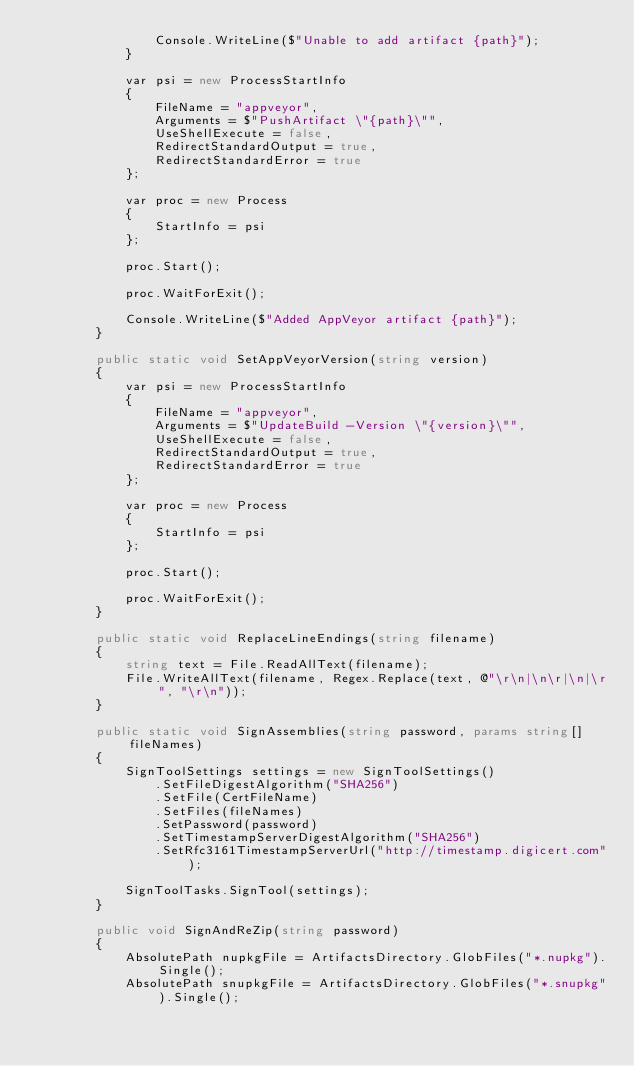Convert code to text. <code><loc_0><loc_0><loc_500><loc_500><_C#_>                Console.WriteLine($"Unable to add artifact {path}");
            }

            var psi = new ProcessStartInfo
            {
                FileName = "appveyor",
                Arguments = $"PushArtifact \"{path}\"",
                UseShellExecute = false,
                RedirectStandardOutput = true,
                RedirectStandardError = true
            };

            var proc = new Process
            {
                StartInfo = psi
            };

            proc.Start();

            proc.WaitForExit();

            Console.WriteLine($"Added AppVeyor artifact {path}");
        }

        public static void SetAppVeyorVersion(string version)
        {
            var psi = new ProcessStartInfo
            {
                FileName = "appveyor",
                Arguments = $"UpdateBuild -Version \"{version}\"",
                UseShellExecute = false,
                RedirectStandardOutput = true,
                RedirectStandardError = true
            };

            var proc = new Process
            {
                StartInfo = psi
            };

            proc.Start();

            proc.WaitForExit();
        }

        public static void ReplaceLineEndings(string filename)
        {
            string text = File.ReadAllText(filename);
            File.WriteAllText(filename, Regex.Replace(text, @"\r\n|\n\r|\n|\r", "\r\n"));
        }

        public static void SignAssemblies(string password, params string[] fileNames)
        {
            SignToolSettings settings = new SignToolSettings()
                .SetFileDigestAlgorithm("SHA256")
                .SetFile(CertFileName)
                .SetFiles(fileNames)
                .SetPassword(password)
                .SetTimestampServerDigestAlgorithm("SHA256")
                .SetRfc3161TimestampServerUrl("http://timestamp.digicert.com");

            SignToolTasks.SignTool(settings);
        }

        public void SignAndReZip(string password)
        {
            AbsolutePath nupkgFile = ArtifactsDirectory.GlobFiles("*.nupkg").Single();
            AbsolutePath snupkgFile = ArtifactsDirectory.GlobFiles("*.snupkg").Single();</code> 